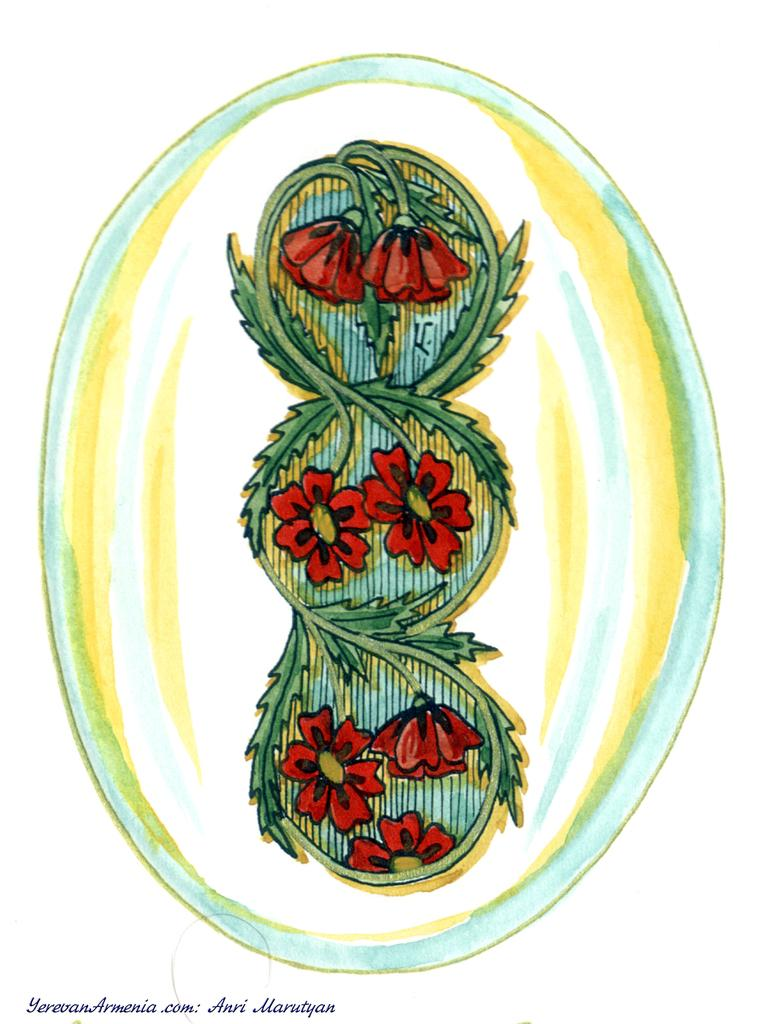What type of flowers can be seen in the image? There are red color flowers in the image. What other elements can be observed in the image besides the flowers? There are green leaves in the image. What colors are present in the image besides red and green? There are yellow, white, and blue colors present in the image. What is the color of the background in the image? The background of the image is white. Where is the seat located in the image? There is no seat present in the image. What type of yam is being prepared in the image? There is no yam or any food preparation visible in the image. 